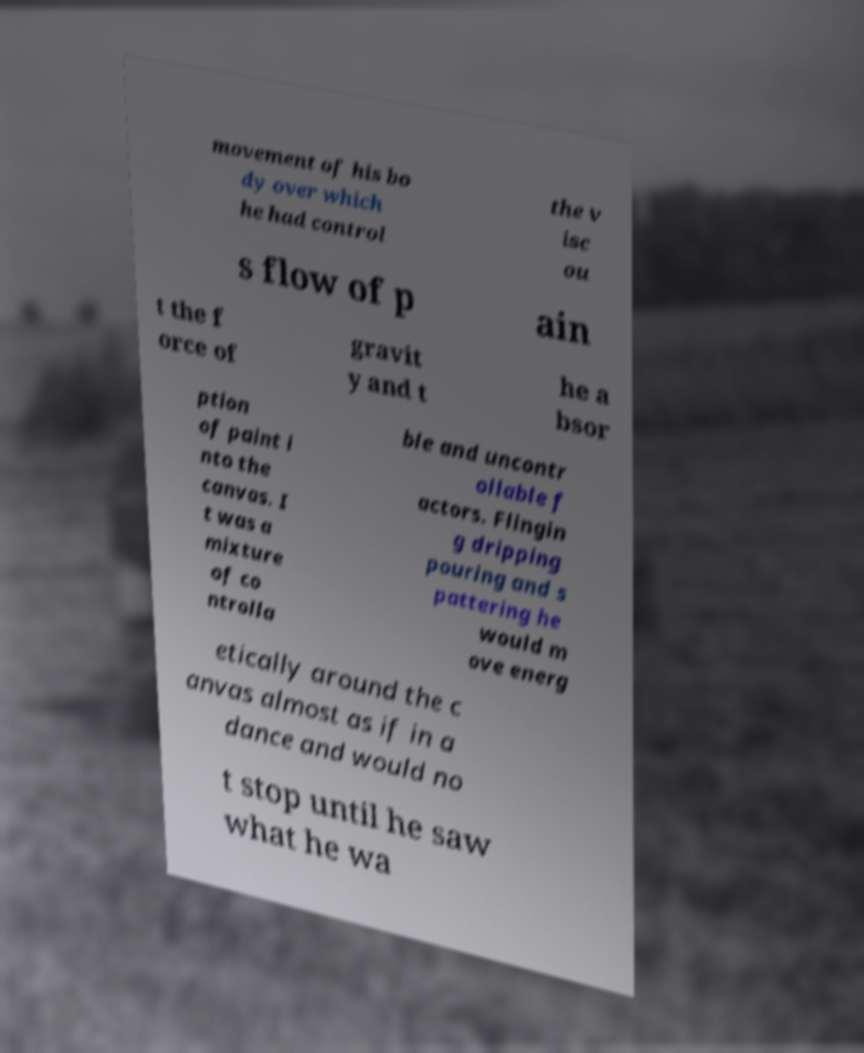Please identify and transcribe the text found in this image. movement of his bo dy over which he had control the v isc ou s flow of p ain t the f orce of gravit y and t he a bsor ption of paint i nto the canvas. I t was a mixture of co ntrolla ble and uncontr ollable f actors. Flingin g dripping pouring and s pattering he would m ove energ etically around the c anvas almost as if in a dance and would no t stop until he saw what he wa 